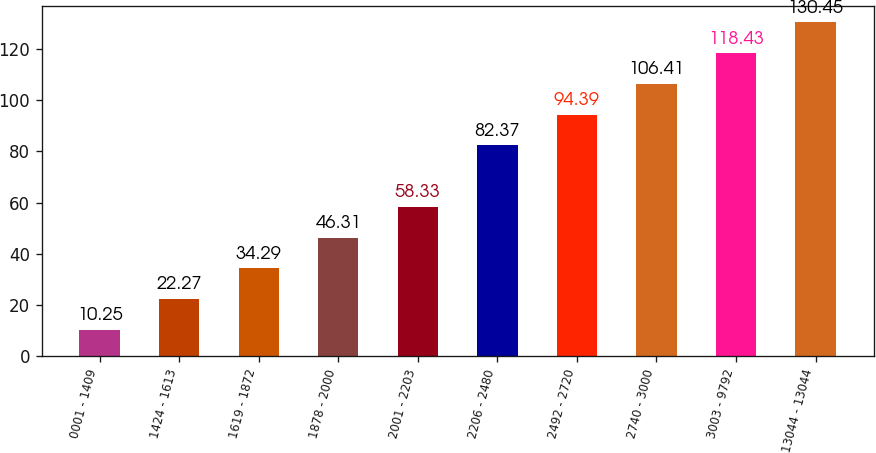Convert chart to OTSL. <chart><loc_0><loc_0><loc_500><loc_500><bar_chart><fcel>0001 - 1409<fcel>1424 - 1613<fcel>1619 - 1872<fcel>1878 - 2000<fcel>2001 - 2203<fcel>2206 - 2480<fcel>2492 - 2720<fcel>2740 - 3000<fcel>3003 - 9792<fcel>13044 - 13044<nl><fcel>10.25<fcel>22.27<fcel>34.29<fcel>46.31<fcel>58.33<fcel>82.37<fcel>94.39<fcel>106.41<fcel>118.43<fcel>130.45<nl></chart> 